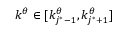Convert formula to latex. <formula><loc_0><loc_0><loc_500><loc_500>k ^ { \theta } \in [ k _ { j ^ { * } - 1 } ^ { \theta } , k _ { j ^ { * } + 1 } ^ { \theta } ]</formula> 